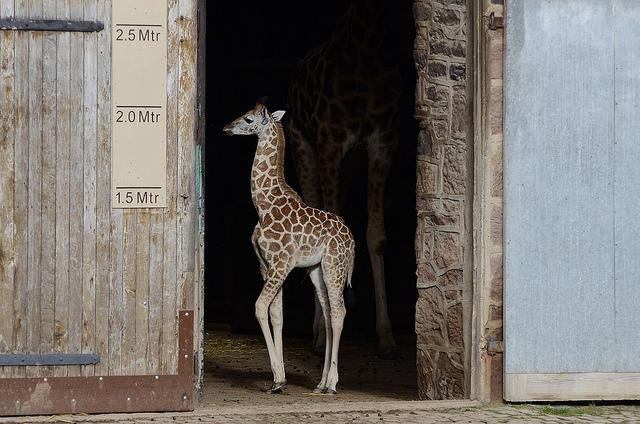Which way is the giraffe facing?
Write a very short answer. Left. Is the giraffe an adult?
Keep it brief. No. How tall is the giraffe?
Keep it brief. 2 meters. 